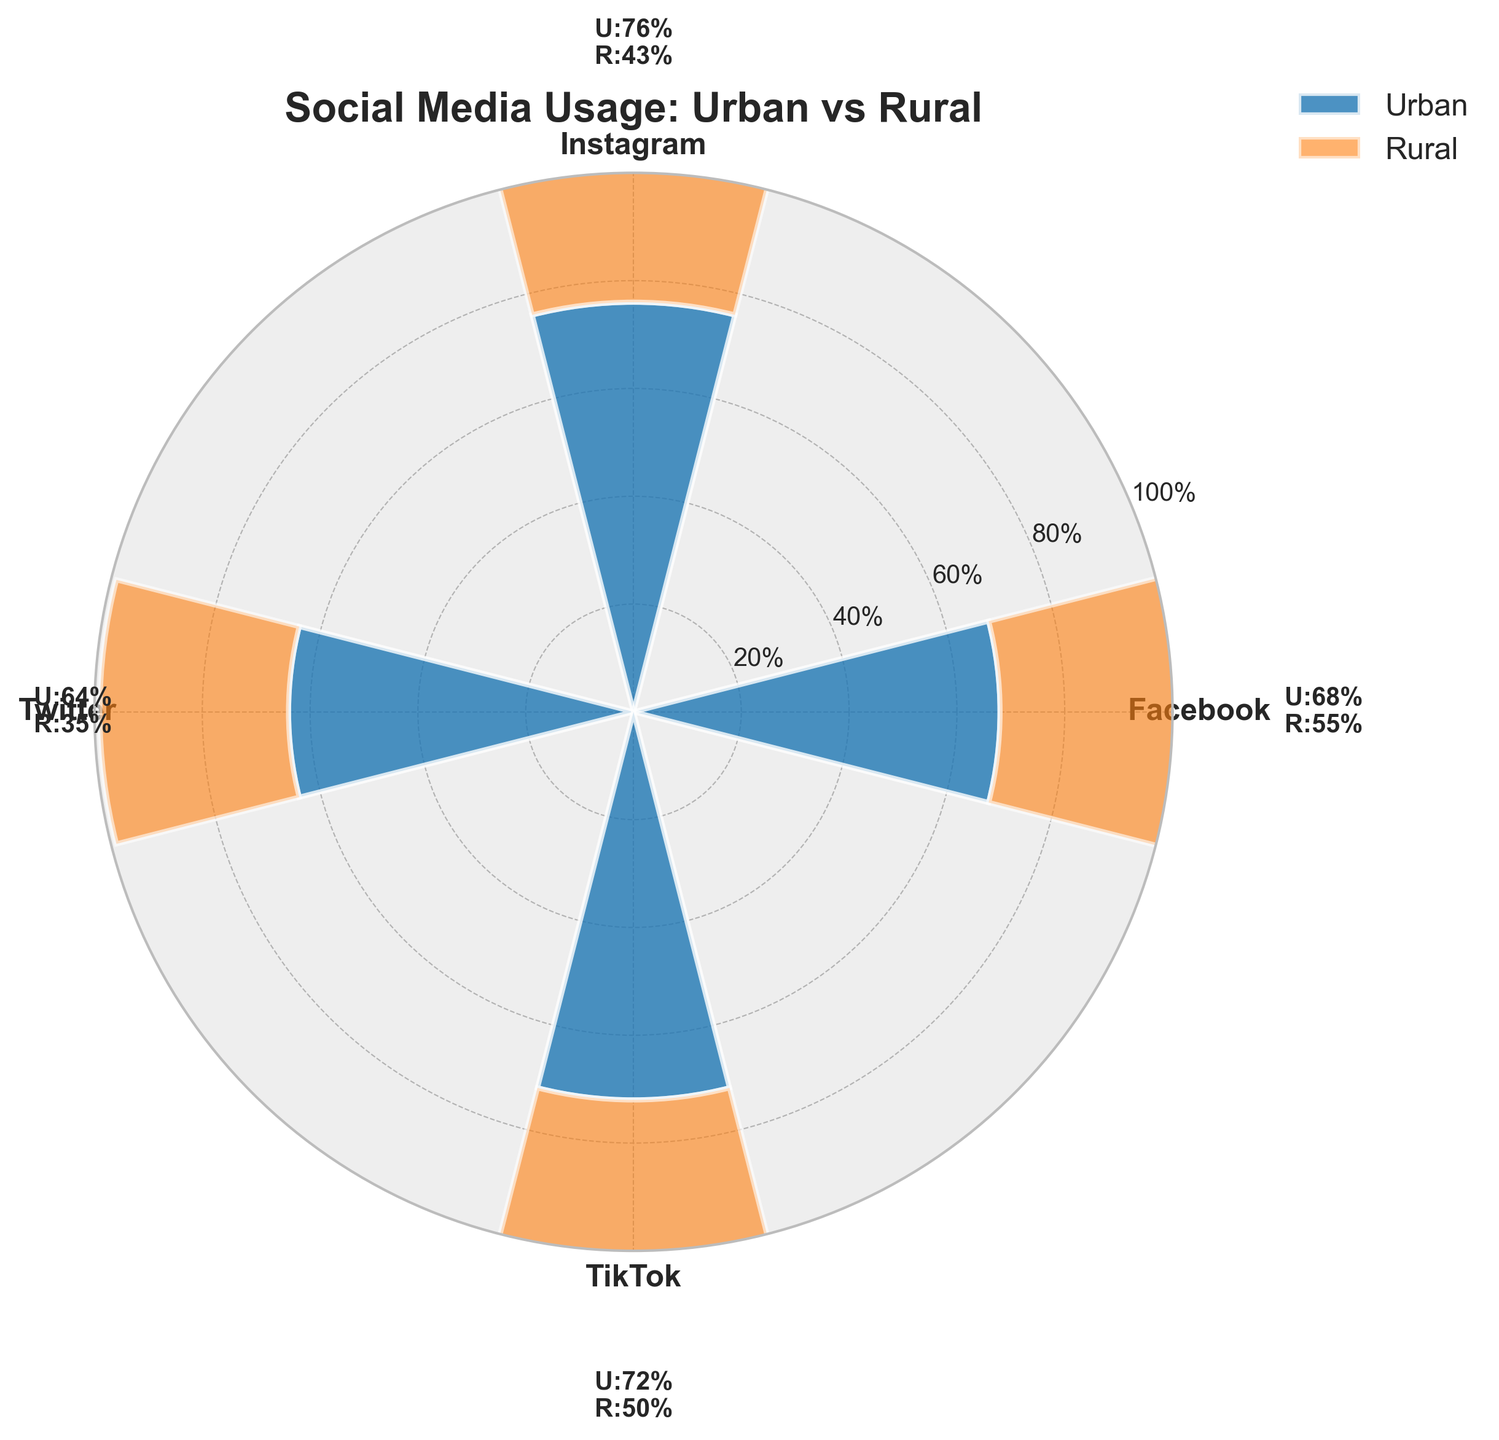What is the title of the figure? The title is displayed at the top of the figure and indicates the main topic of the plot. In this case, the title is "Social Media Usage: Urban vs Rural."
Answer: Social Media Usage: Urban vs Rural Which social media platform has the highest usage percentage in urban areas? By looking at the lengths of the bars in the "Urban" section, Instagram has the highest usage percentage in urban areas.
Answer: Instagram Compare the usage percentage of Twitter between urban and rural areas. Twitter usage is indicated by two adjacent bars, one for urban and one for rural. The urban usage is 64%, and the rural usage is 35%. Subtracting these two gives the difference.
Answer: Urban: 64%, Rural: 35% (Difference: 29%) What is the combined usage percentage of Facebook in both urban and rural areas? The vertical heights of the stacked bars for Facebook in both areas represent their usage. Adding 68% (urban) and 55% (rural) gives the total.
Answer: 123% Which area shows a higher usage percentage for TikTok, and by how much? Compare the lengths of the TikTok bars for both areas. TikTok usage in urban areas is 72%, and in rural areas, it's 50%. Subtract the rural percentage from the urban percentage.
Answer: Urban (22% higher) List the social media platforms in descending order of rural usage percentage. Examine the rural usage bars for all platforms. Arrange these from the tallest to shortest to get the order: Facebook, TikTok, Instagram, Twitter.
Answer: Facebook, TikTok, Instagram, Twitter What is the average usage percentage of Instagram across both urban and rural areas? Add the Instagram usage percentages (76% for urban and 43% for rural) and then divide by 2 to get the average.
Answer: 59.5% Which social media platform has the smallest difference in usage percentage between urban and rural areas? Calculate the differences for all platforms (Facebook: 13%, Instagram: 33%, Twitter: 29%, TikTok: 22%), and find the smallest value.
Answer: Facebook Are there any platforms where rural usage exceeds 50%? Check the bar lengths for each rural area. Facebook and TikTok have rural usage percentages that qualify.
Answer: Facebook and TikTok 